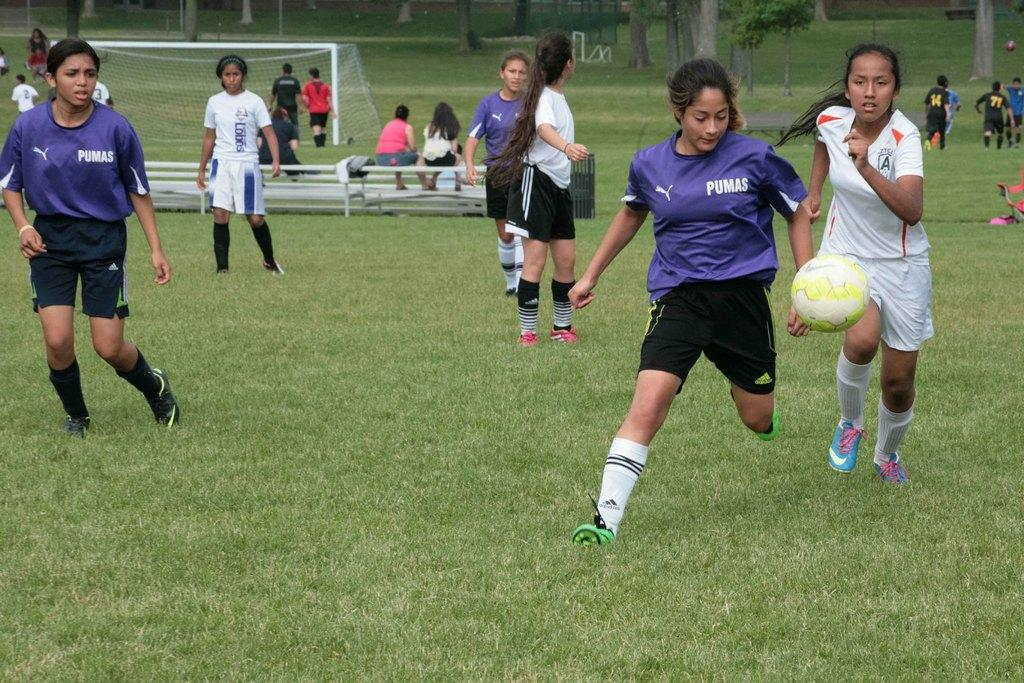<image>
Present a compact description of the photo's key features. The Pumas player is about to kick the soccer ball. 